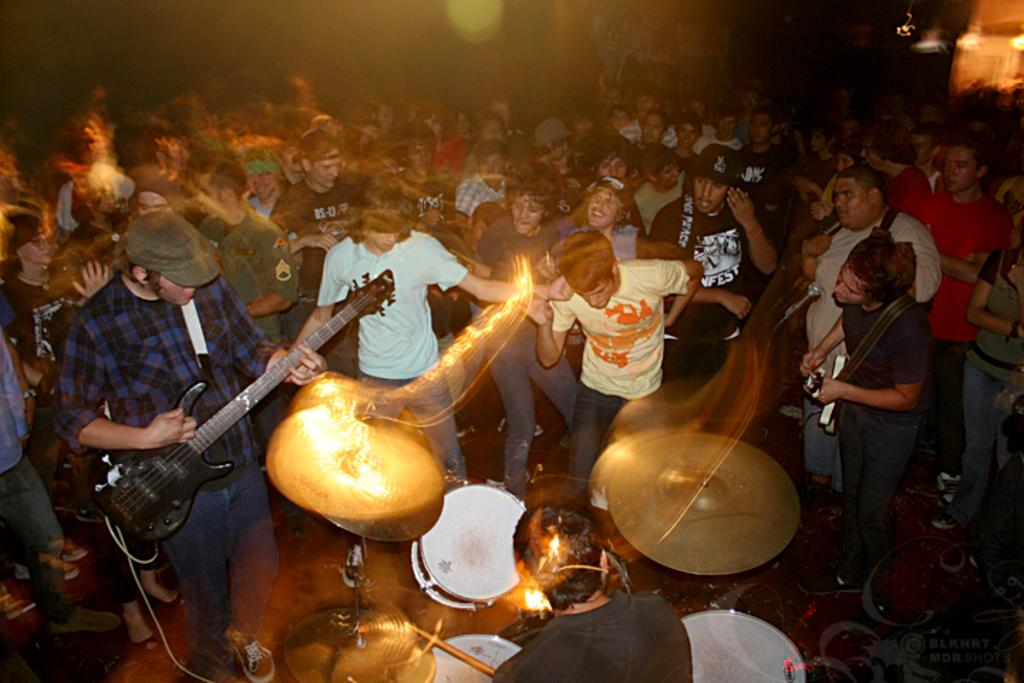How many people are in the image? There are people in the image. What are two of the people doing in the image? Two people are playing guitars. What else can be seen in front of the person playing the guitar? There are musical instruments in front of the person playing the guitar. What type of snow can be seen falling in the image? There is no snow present in the image. What invention is being demonstrated by the people in the image? The image does not depict any specific invention being demonstrated. 